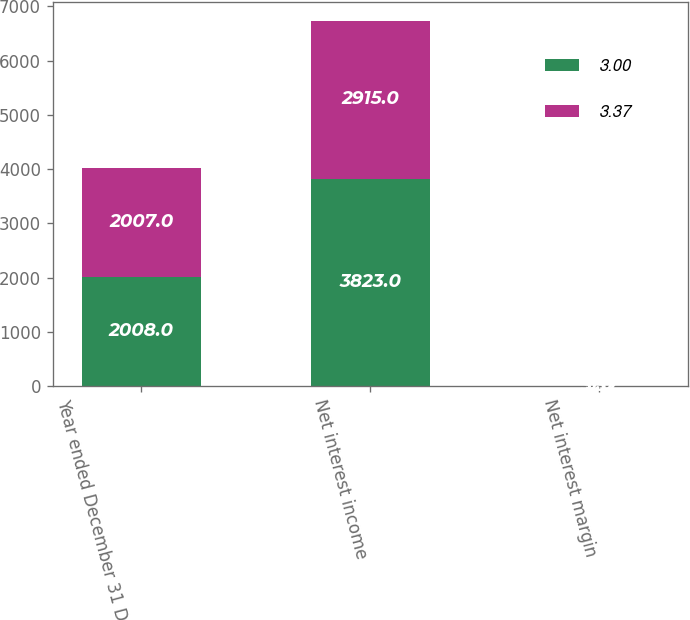<chart> <loc_0><loc_0><loc_500><loc_500><stacked_bar_chart><ecel><fcel>Year ended December 31 Dollars<fcel>Net interest income<fcel>Net interest margin<nl><fcel>3<fcel>2008<fcel>3823<fcel>3.37<nl><fcel>3.37<fcel>2007<fcel>2915<fcel>3<nl></chart> 